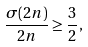<formula> <loc_0><loc_0><loc_500><loc_500>\frac { \sigma ( 2 n ) } { 2 n } \geq \frac { 3 } { 2 } ,</formula> 